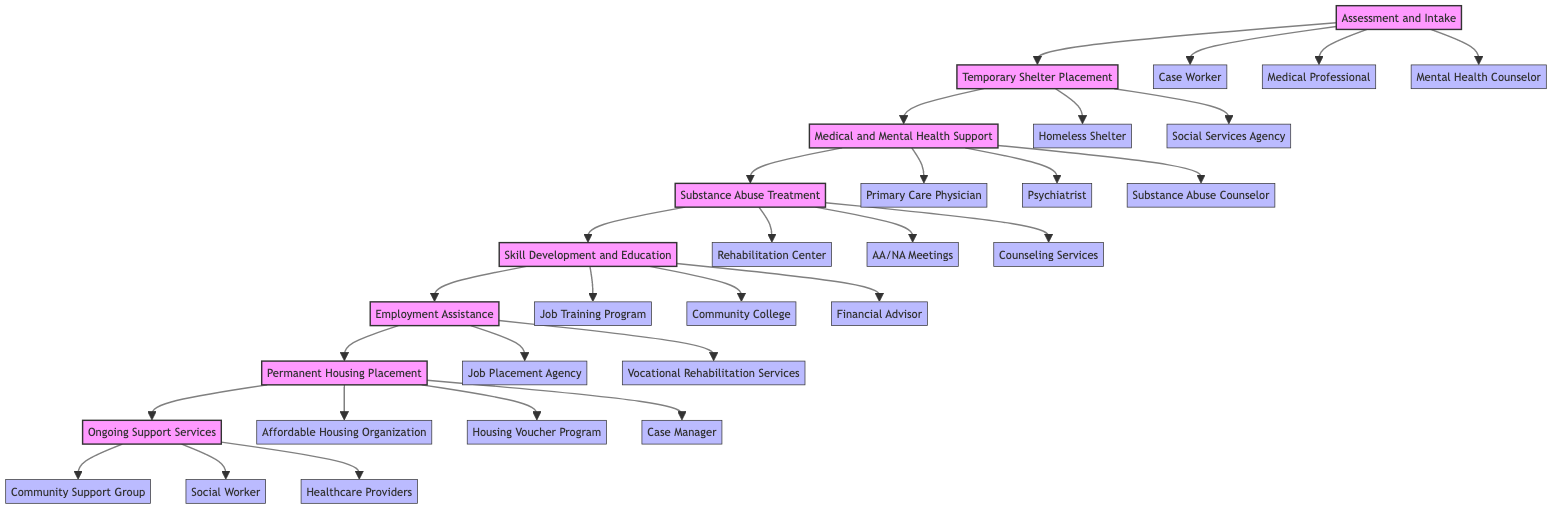What is the first step in the diagram? The diagram starts with the "Assessment and Intake" step, which is the first node in the flow.
Answer: Assessment and Intake How many entities are listed under "Substance Abuse Treatment"? Under "Substance Abuse Treatment," there are three entities: Rehabilitation Center, AA/NA Meetings, and Counseling Services.
Answer: 3 Which step directly follows "Skill Development and Education"? The step that directly follows "Skill Development and Education" in the flowchart is "Employment Assistance." This is evident from the flow direction in the diagram.
Answer: Employment Assistance What type of support is offered in the final step? The final step "Ongoing Support Services" indicates continuous support necessary for maintaining independent living. This step emphasizes ongoing assistance rather than initial placement or treatment.
Answer: Continuous support How many total steps are included in the process? By counting the distinct steps in the flowchart, there are a total of eight steps from the beginning to the end of the process.
Answer: 8 What is required before moving to "Permanent Housing Placement"? Before transitioning to "Permanent Housing Placement," a person must go through the steps of "Employment Assistance," which indicates obtaining stable employment is a prerequisite.
Answer: Employment Assistance What entities are involved in "Medical and Mental Health Support"? The entities involved in "Medical and Mental Health Support" include a Primary Care Physician, Psychiatrist, and Substance Abuse Counselor, which are listed under that step in the diagram.
Answer: Primary Care Physician, Psychiatrist, Substance Abuse Counselor Which step includes job skill training? "Skill Development and Education" is the step focused on providing training necessary for job skills and financial literacy, making it clear that this is where job skill training occurs.
Answer: Skill Development and Education Identify the last entity connected to the flowchart. The last entity related to the final node "Ongoing Support Services" includes Community Support Group, Social Worker, and Healthcare Providers, where the support continues post-transition.
Answer: Community Support Group, Social Worker, Healthcare Providers 